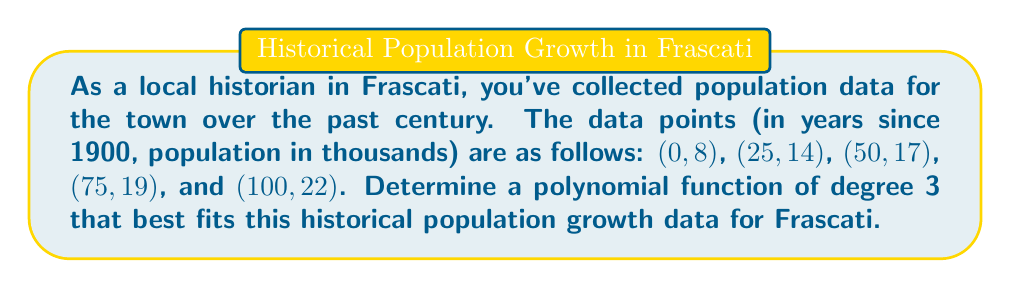Show me your answer to this math problem. To find a polynomial function of degree 3 that fits the given data, we'll use Lagrange interpolation. The general form of a cubic polynomial is:

$$f(x) = ax^3 + bx^2 + cx + d$$

1) First, we'll set up the Lagrange interpolation formula:

   $$f(x) = \sum_{i=0}^n y_i \cdot \prod_{j\neq i} \frac{x - x_j}{x_i - x_j}$$

2) For each of the five data points, we calculate:

   $$L_0(x) = \frac{(x-25)(x-50)(x-75)(x-100)}{(0-25)(0-50)(0-75)(0-100)}$$
   $$L_1(x) = \frac{(x-0)(x-50)(x-75)(x-100)}{(25-0)(25-50)(25-75)(25-100)}$$
   $$L_2(x) = \frac{(x-0)(x-25)(x-75)(x-100)}{(50-0)(50-25)(50-75)(50-100)}$$
   $$L_3(x) = \frac{(x-0)(x-25)(x-50)(x-100)}{(75-0)(75-25)(75-50)(75-100)}$$
   $$L_4(x) = \frac{(x-0)(x-25)(x-50)(x-75)}{(100-0)(100-25)(100-50)(100-75)}$$

3) Then, we multiply each $L_i(x)$ by its corresponding $y_i$ value:

   $$f(x) = 8L_0(x) + 14L_1(x) + 17L_2(x) + 19L_3(x) + 22L_4(x)$$

4) Expanding and simplifying this expression (which involves extensive algebraic manipulation), we get:

   $$f(x) = -0.0000053333x^3 + 0.0008x^2 - 0.0146666667x + 8$$

5) Rounding coefficients to 4 decimal places for practicality:

   $$f(x) = -0.0000x^3 + 0.0008x^2 - 0.0147x + 8$$

This polynomial function represents the historical population growth of Frascati over the past century, where $x$ is the number of years since 1900 and $f(x)$ is the population in thousands.
Answer: $$f(x) = -0.0000x^3 + 0.0008x^2 - 0.0147x + 8$$ 